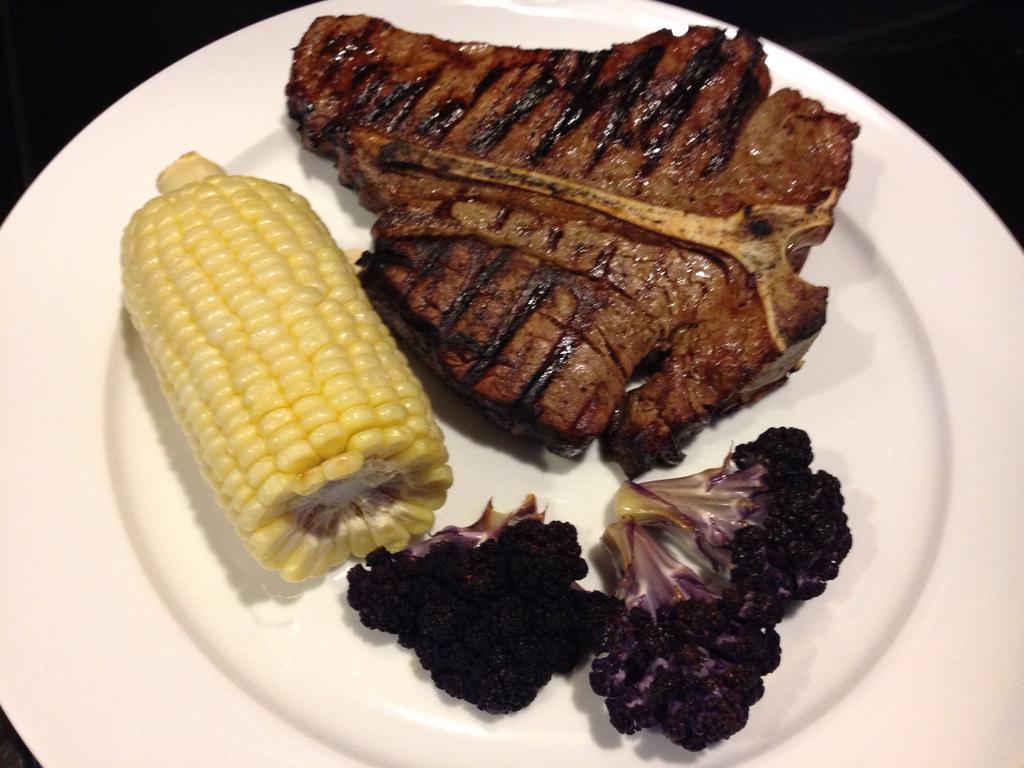Please provide a concise description of this image. In this image on a plate there is meat, vegetable and corn is there. 